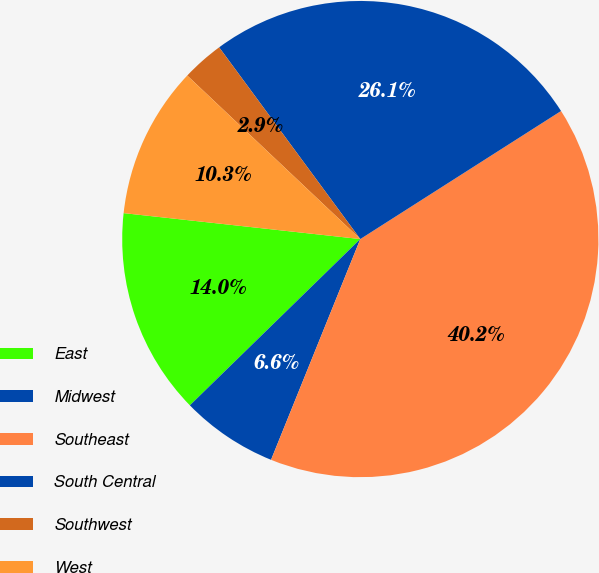<chart> <loc_0><loc_0><loc_500><loc_500><pie_chart><fcel>East<fcel>Midwest<fcel>Southeast<fcel>South Central<fcel>Southwest<fcel>West<nl><fcel>14.04%<fcel>6.58%<fcel>40.15%<fcel>26.06%<fcel>2.85%<fcel>10.31%<nl></chart> 